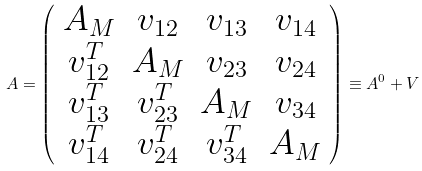Convert formula to latex. <formula><loc_0><loc_0><loc_500><loc_500>A = \left ( \begin{array} { c c c c } A _ { M } & v _ { 1 2 } & v _ { 1 3 } & v _ { 1 4 } \\ v ^ { T } _ { 1 2 } & A _ { M } & v _ { 2 3 } & v _ { 2 4 } \\ v ^ { T } _ { 1 3 } & v ^ { T } _ { 2 3 } & A _ { M } & v _ { 3 4 } \\ v ^ { T } _ { 1 4 } & v ^ { T } _ { 2 4 } & v ^ { T } _ { 3 4 } & A _ { M } \end{array} \right ) \equiv A ^ { 0 } + V</formula> 